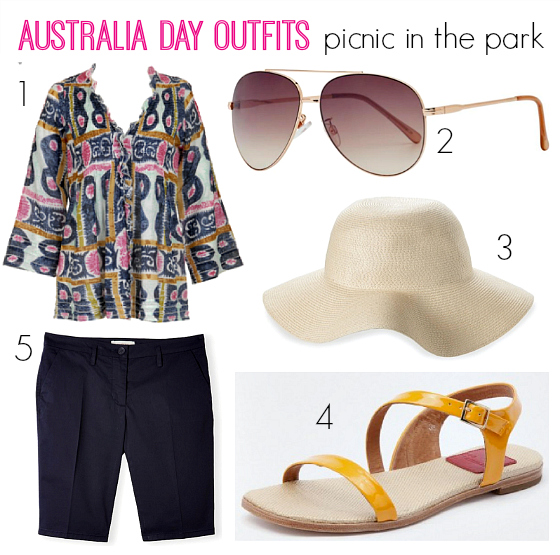Could the sun hat be considered suitable for both formal and casual occasions? Based on the provided image, the sun hat features a clean and straightforward yet chic design characterized by its neutral beige shade and high-quality weave. The hat's relaxed, floppy style coupled with its broad brim suggests comfort and casual wear — ideal for a laid-back setting like a beach or a park. At the same time, this hat exudes an elemental elegance that, when paired with the right accessories, could be suited for more formal outdoor events such as garden parties or outdoor weddings. Its versatility in adapting to various outfits and occasions makes it a suitable choice for both casual and formal events. 